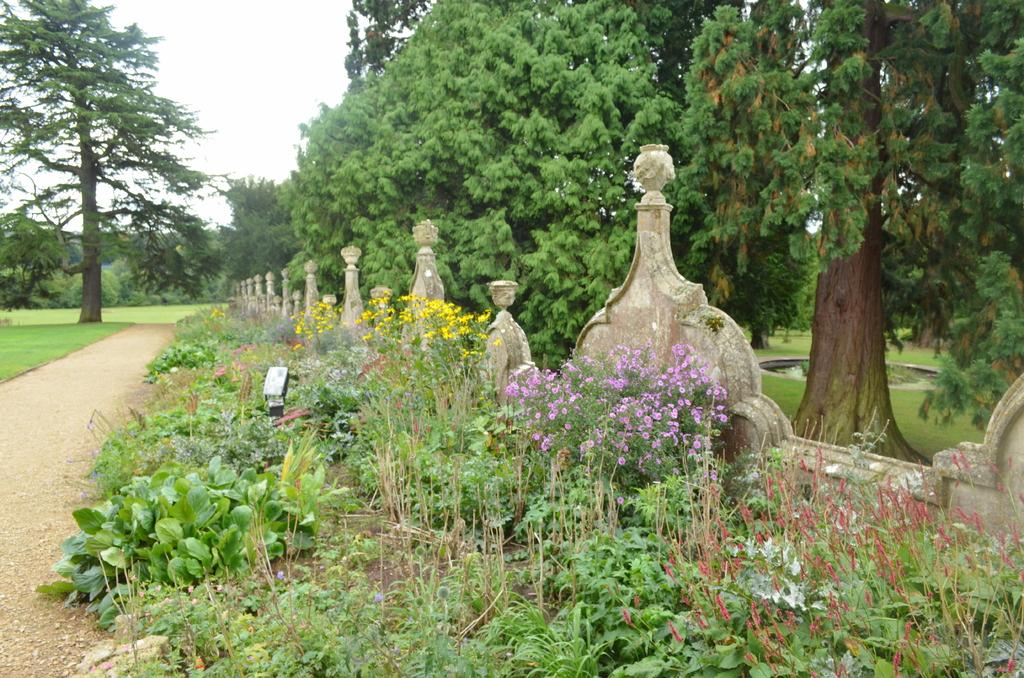What type of vegetation can be seen in the image? There are trees, plants, and flowers visible in the image. What kind of barrier is present in the image? There is a fence in the image. What is the ground covered with in the image? Grass is visible on the ground in the image. What is the condition of the sky in the image? The sky is cloudy in the image. Can you locate the map in the image? There is no map present in the image. What type of beam is holding up the tree in the image? There is no beam present in the image, and trees are not supported by beams. 